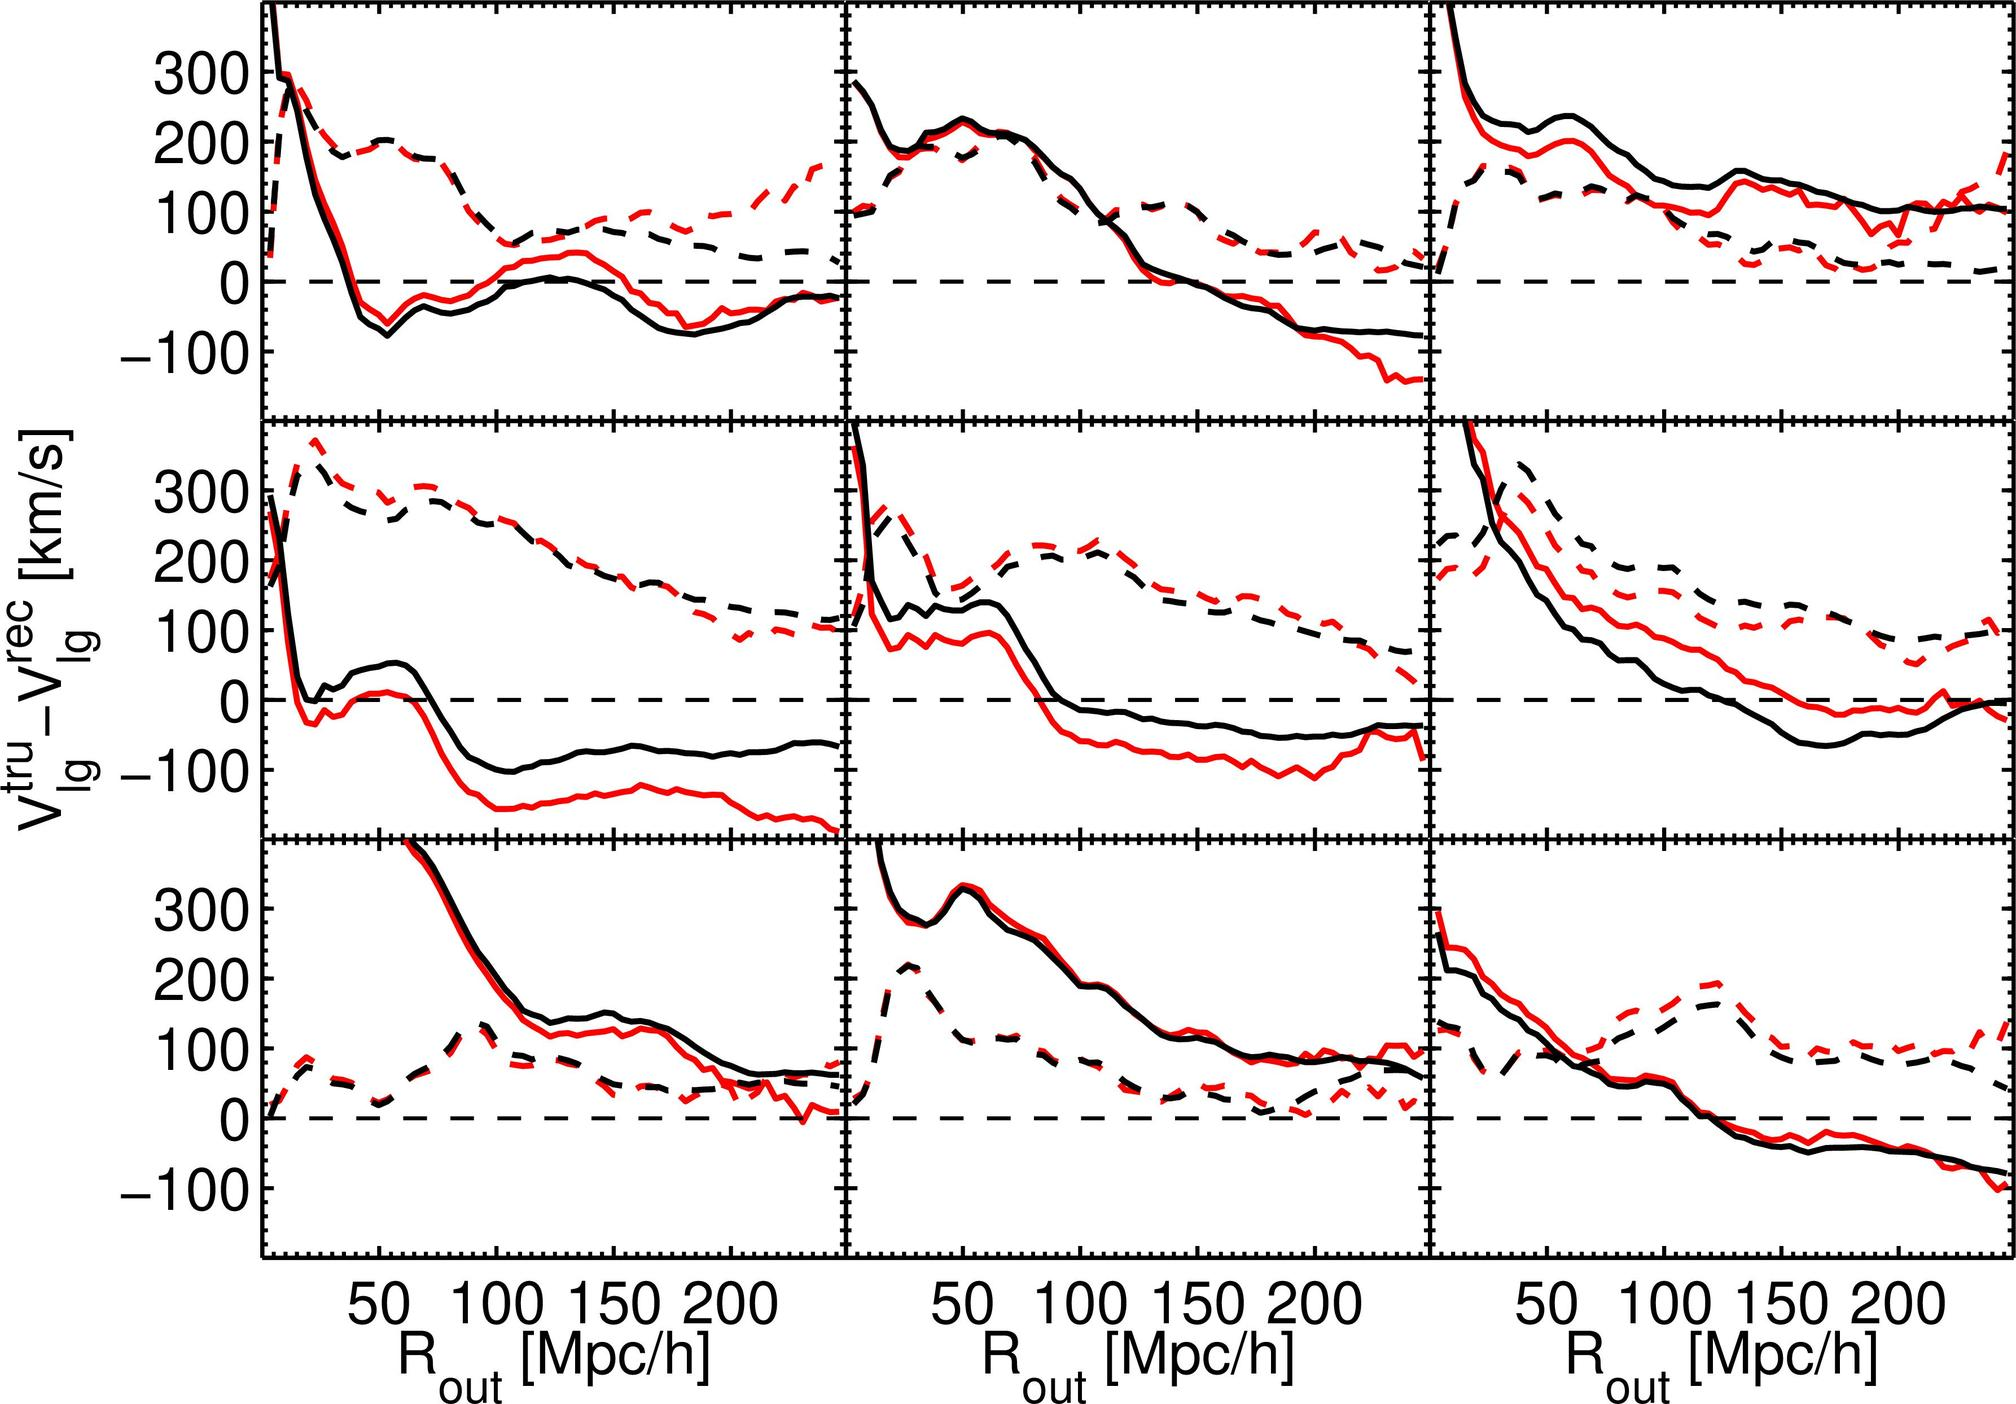What does the dashed line represent in these plots? The dashed lines in these plots are typically used to represent a theoretical prediction or a model output that is being compared against actual observational data, marked by the solid lines. In the context of these graphs, which plot the difference in velocity of local galaxies against a baseline measurement, the dashed line likely indicates a theoretical prediction for these velocity differences. This is crucial in astrophysics for understanding how galaxies might be moving relative to the theorized models of the universe. 